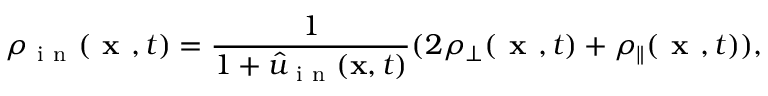Convert formula to latex. <formula><loc_0><loc_0><loc_500><loc_500>\rho _ { i n } ( x , t ) = \frac { 1 } { 1 + \hat { u } _ { i n } ( x , t ) } ( 2 \rho _ { \bot } ( x , t ) + \rho _ { \| } ( x , t ) ) ,</formula> 